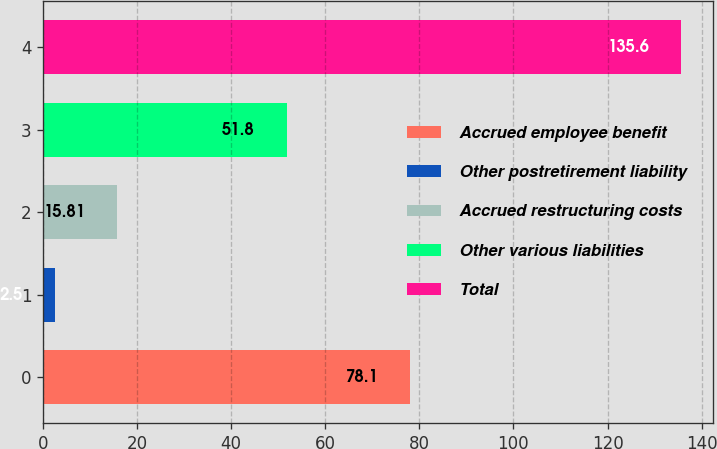Convert chart. <chart><loc_0><loc_0><loc_500><loc_500><bar_chart><fcel>Accrued employee benefit<fcel>Other postretirement liability<fcel>Accrued restructuring costs<fcel>Other various liabilities<fcel>Total<nl><fcel>78.1<fcel>2.5<fcel>15.81<fcel>51.8<fcel>135.6<nl></chart> 